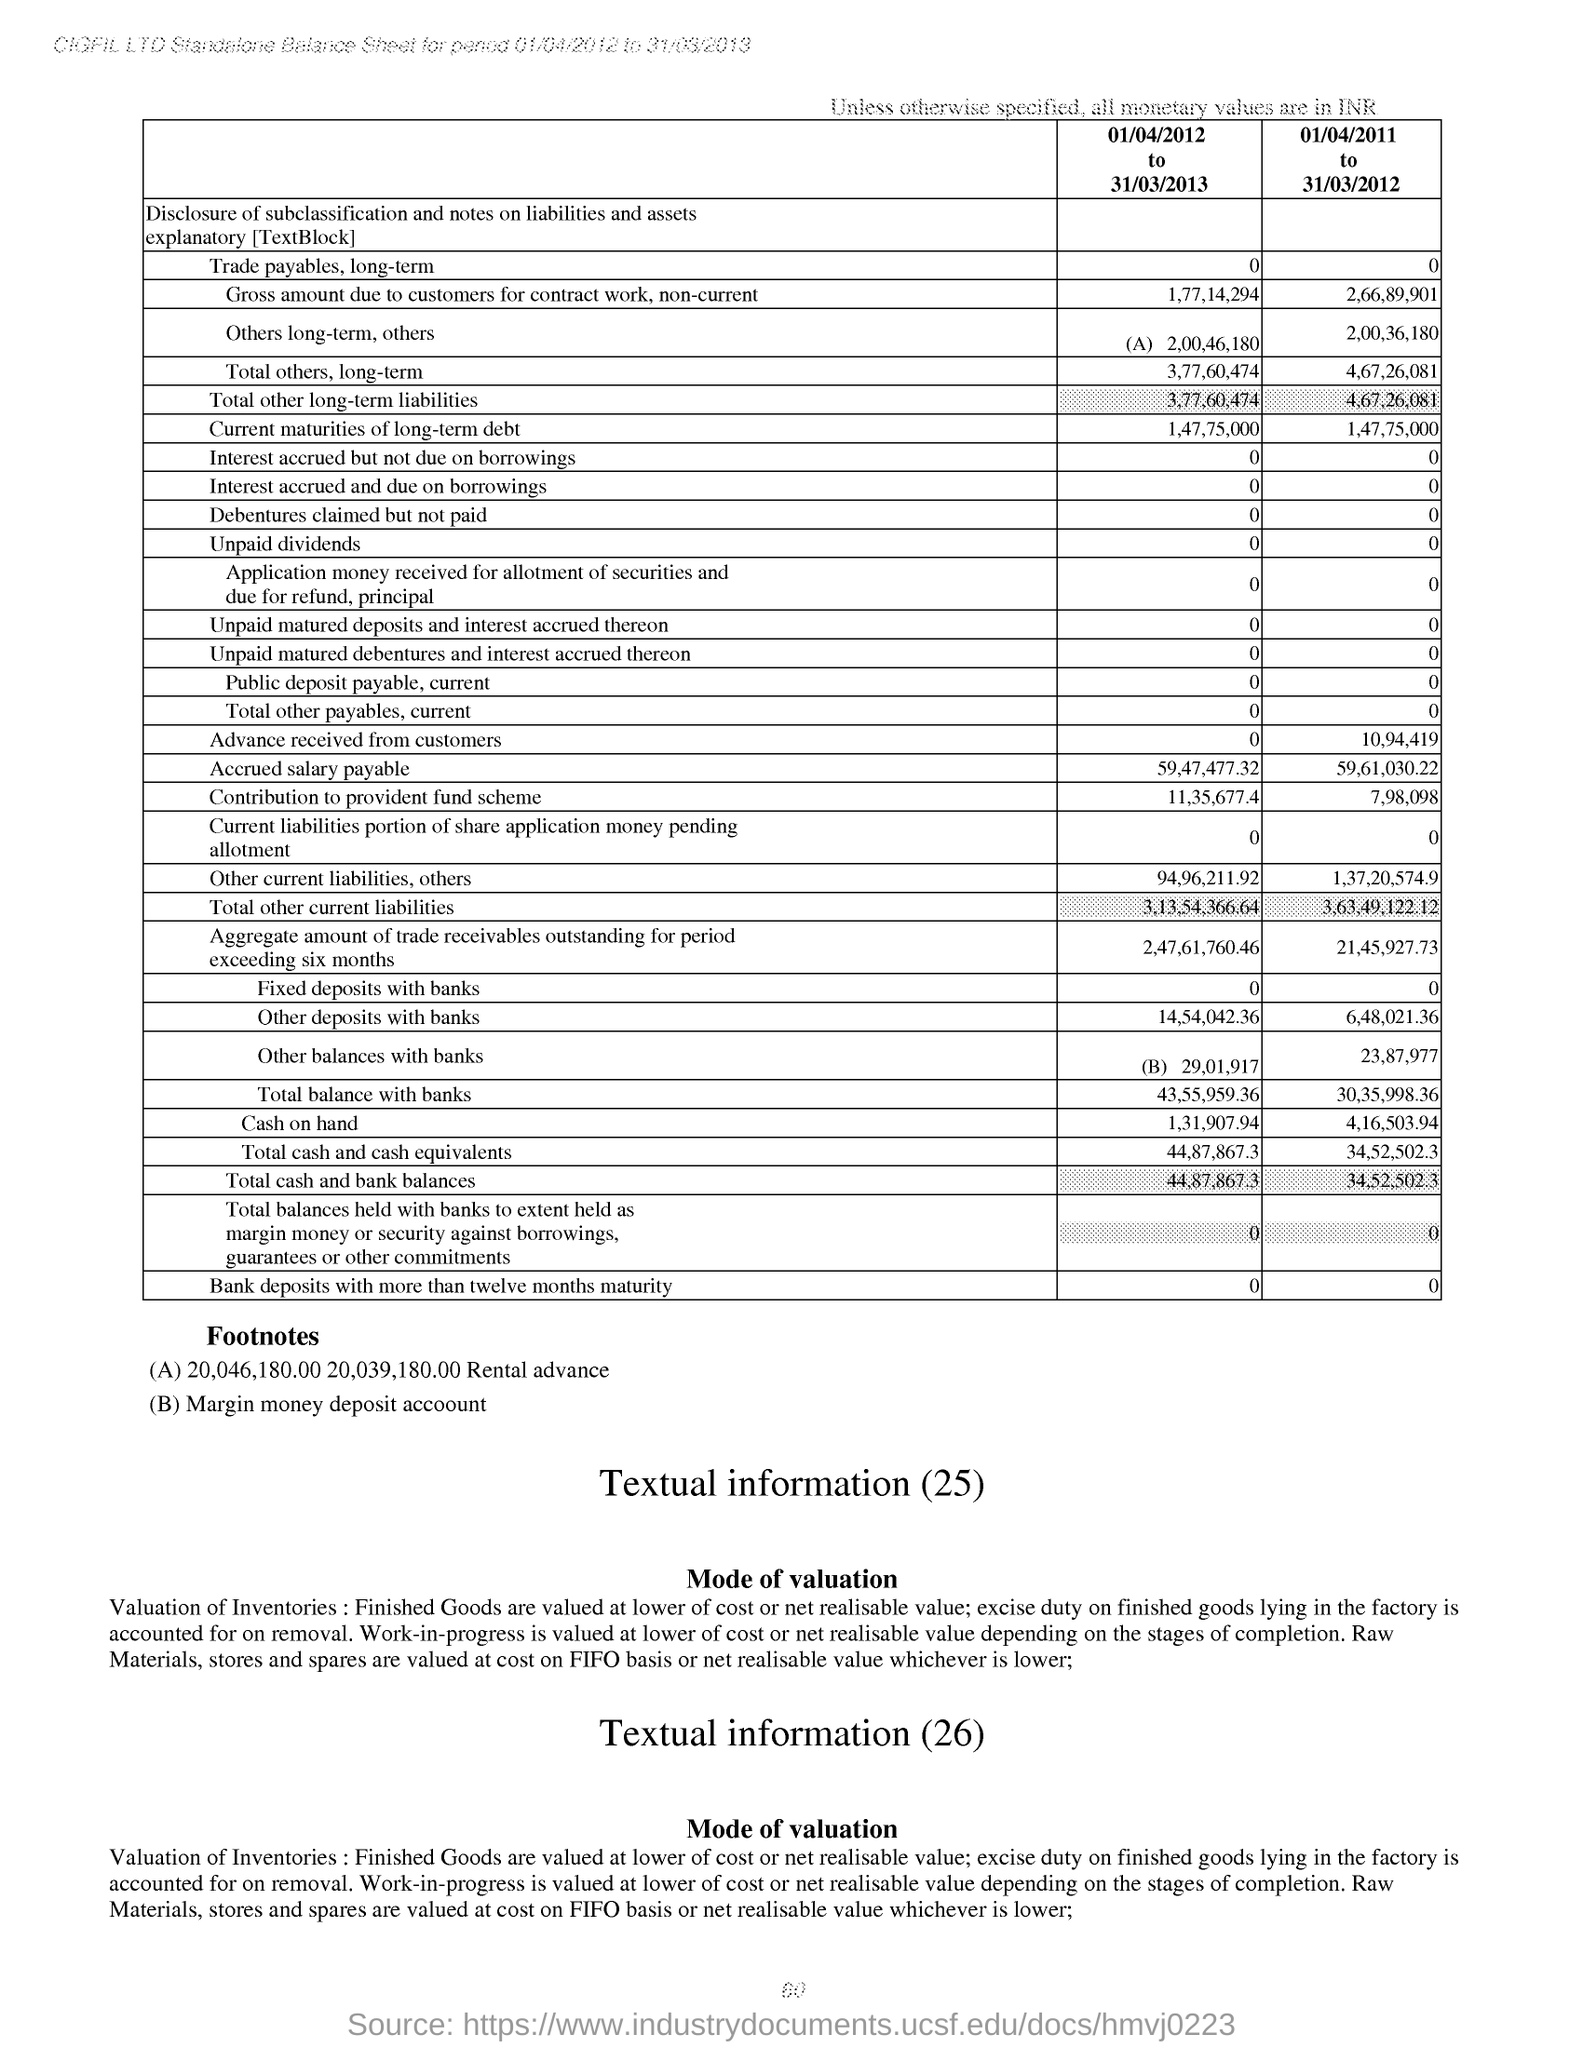How much is the 'Total others, long-term' value for the period '01/04/2012 to 31/03/2013' ?
Make the answer very short. 3,77,60,474. 